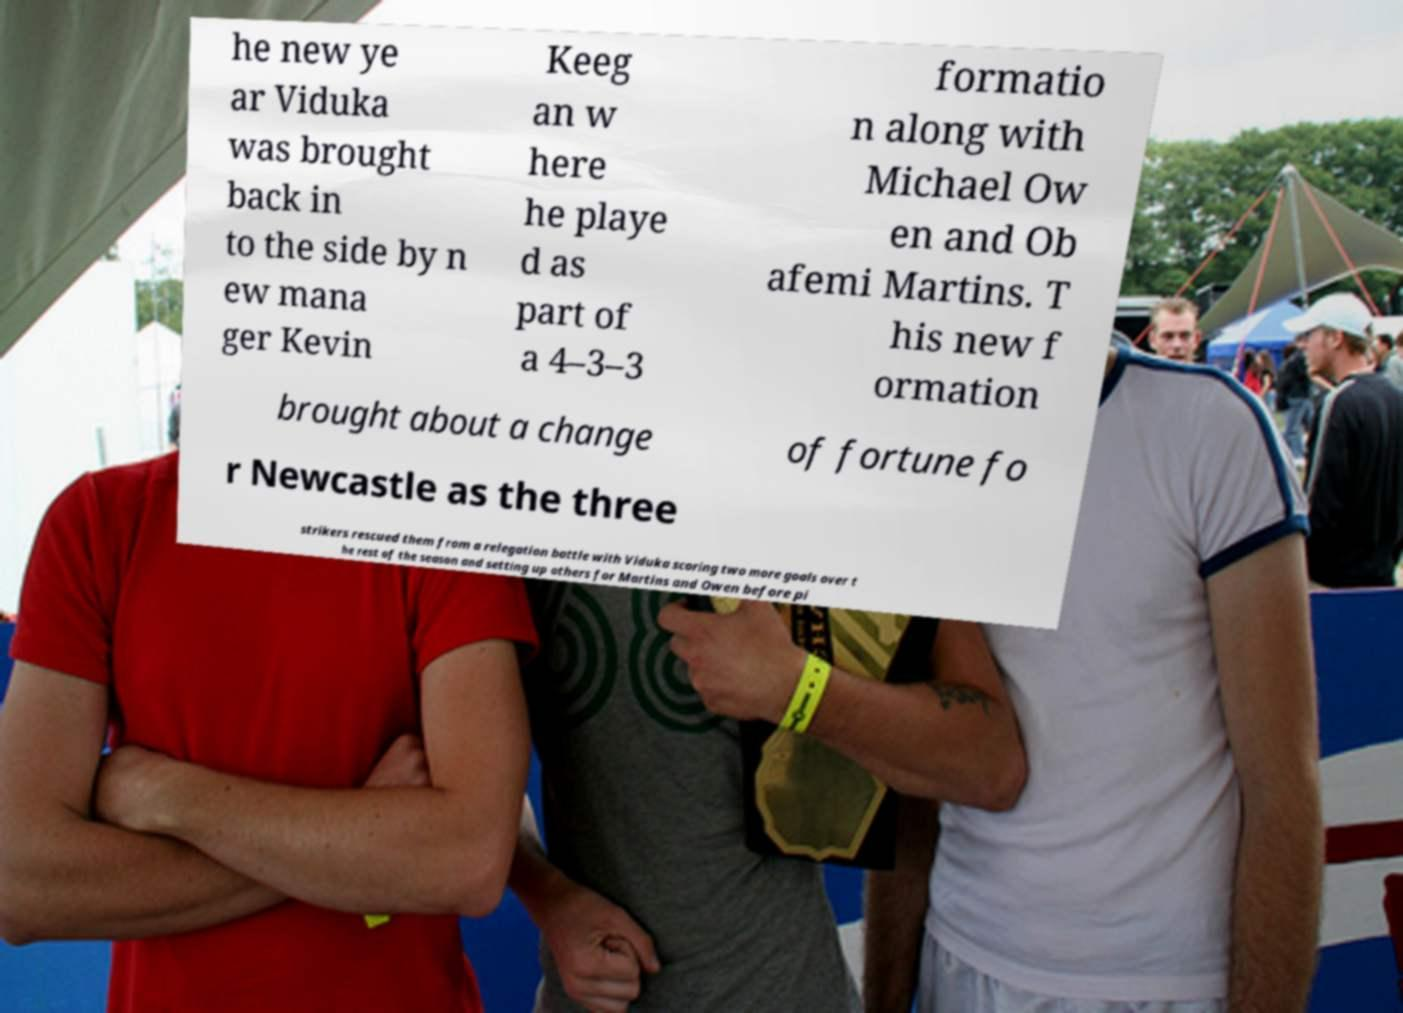Could you extract and type out the text from this image? he new ye ar Viduka was brought back in to the side by n ew mana ger Kevin Keeg an w here he playe d as part of a 4–3–3 formatio n along with Michael Ow en and Ob afemi Martins. T his new f ormation brought about a change of fortune fo r Newcastle as the three strikers rescued them from a relegation battle with Viduka scoring two more goals over t he rest of the season and setting up others for Martins and Owen before pi 